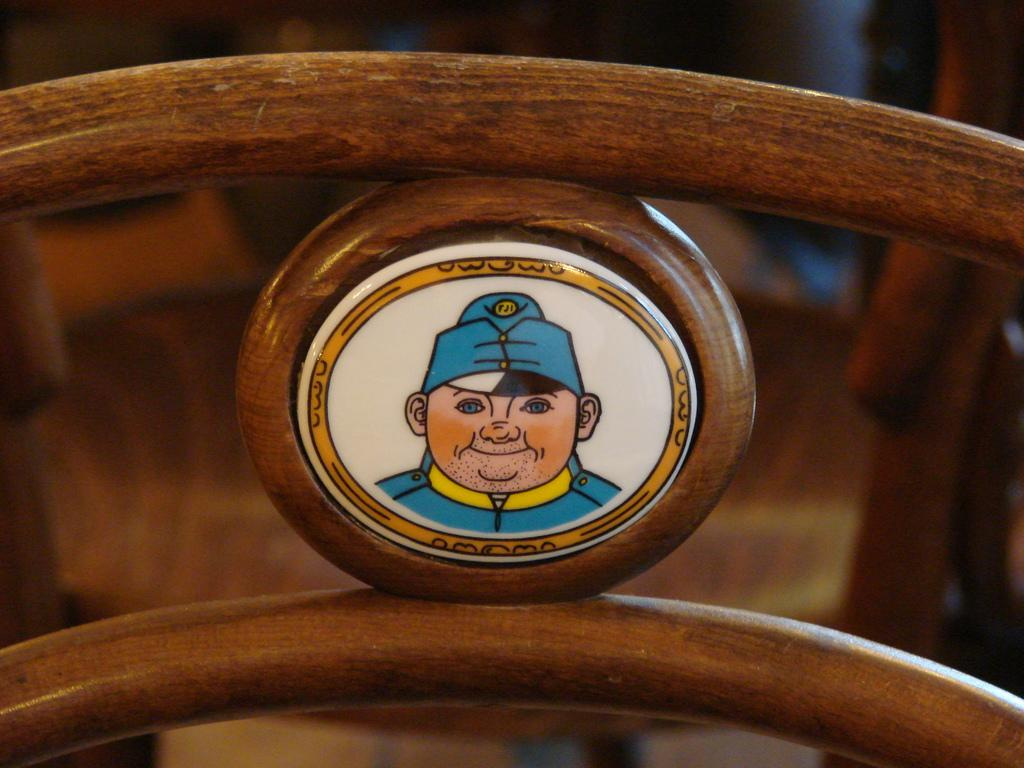What material is the ring surrounding the image made of? The ring surrounding the image is made of wood. What type of objects can be seen in the image? There are wooden objects in the image. How would you describe the background of the image? The background of the image is blurry. What type of flag is visible in the image? There is no flag present in the image. What can be seen in the aftermath of the event depicted in the image? There is no event depicted in the image, so there is no aftermath to observe. 